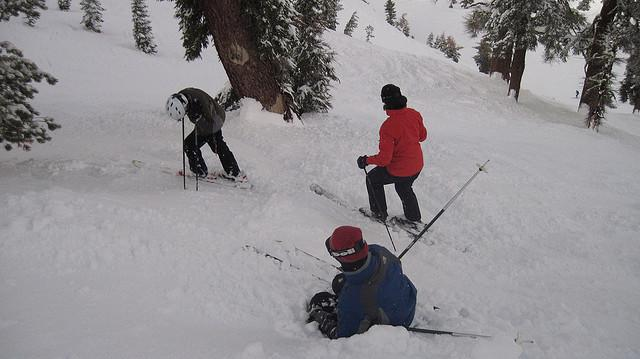How did the person wearing blue come to be in the position they are in?

Choices:
A) marketing
B) escaping
C) falling
D) waking up falling 